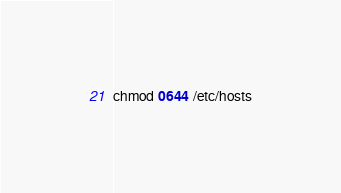<code> <loc_0><loc_0><loc_500><loc_500><_Bash_>chmod 0644 /etc/hosts</code> 